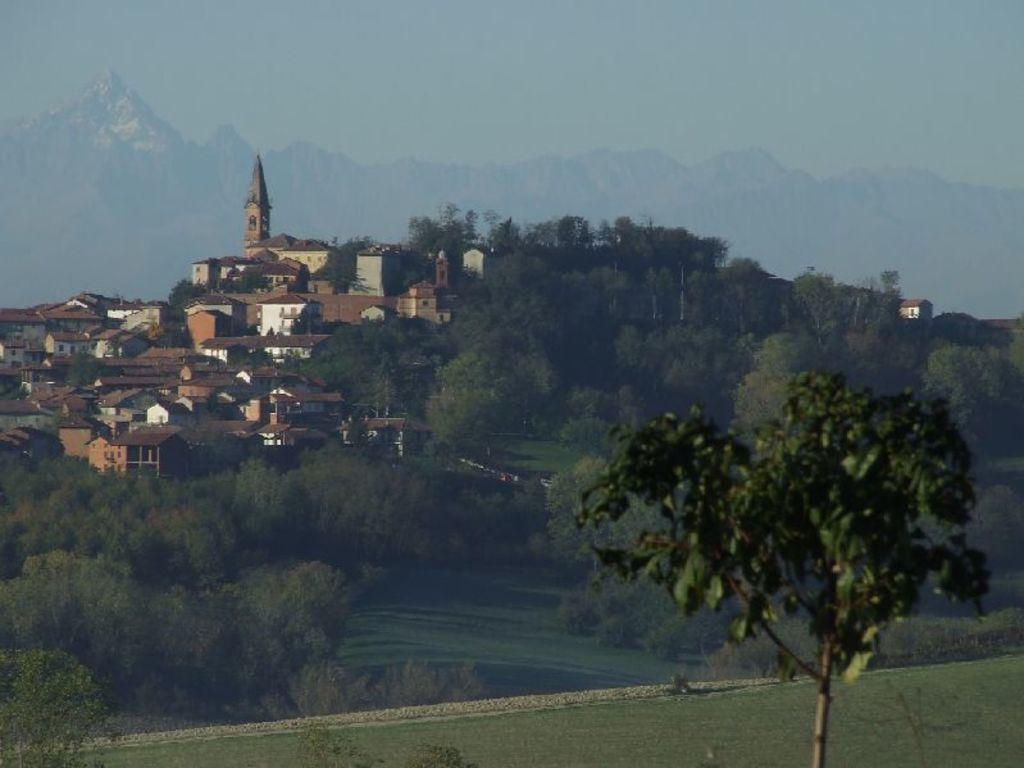Could you give a brief overview of what you see in this image? In this picture I can observe houses on the left side. I can observe trees in this picture. In the background there are hills and sky. 